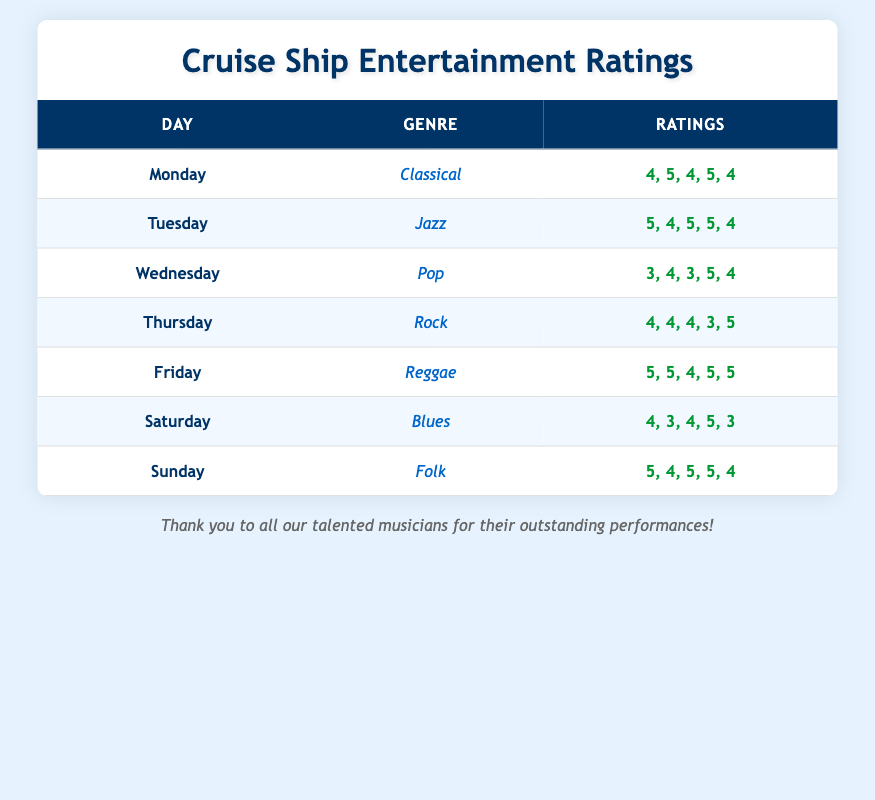What is the rating for Jazz performances on Tuesday? In the table, under the row for Tuesday, the genre is Jazz, and the ratings are listed as 5, 4, 5, 5, 4.
Answer: 5, 4, 5, 5, 4 Which genre received the highest average rating? To find the highest average, we calculate the average rating for each genre. Classical: (4+5+4+5+4)/5 = 4.4, Jazz: (5+4+5+5+4)/5 = 4.6, Pop: (3+4+3+5+4)/5 = 3.8, Rock: (4+4+4+3+5)/5 = 4.0, Reggae: (5+5+4+5+5)/5 = 4.8, Blues: (4+3+4+5+3)/5 = 3.8, Folk: (5+4+5+5+4)/5 = 4.6. The highest average is 4.8 for Reggae.
Answer: Reggae What was the lowest rating for Pop performances? Under the Pop performances on Wednesday, the ratings are 3, 4, 3, 5, 4. The lowest rating visible is 3.
Answer: 3 Did Folk performances receive an average rating above 4? To check this, we calculate the average for Folk: (5+4+5+5+4)/5 = 4.6. Since 4.6 is greater than 4, the average rating is above 4.
Answer: Yes What is the total number of performances rated on Saturday? On Saturday, the Blues performances have 5 ratings listed: 4, 3, 4, 5, 3. Therefore, the total number of performances rated is 5.
Answer: 5 Which day had a performance rating that was all above 4? By examining the table, we find that Tuesday (Jazz: 5, 4, 5, 5, 4) and Friday (Reggae: 5, 5, 4, 5, 5) both have ratings where all numbers are above 4.
Answer: Tuesday and Friday What was the average rating for Rock performances? For Rock on Thursday, the ratings are 4, 4, 4, 3, 5. The average is calculated as (4+4+4+3+5)/5 = 4. The average rating is 4.
Answer: 4 Did any genre receive a perfect rating of 5 on all days? By reviewing the table, no genre has all ratings as 5 across all days. The closest is Reggae with ratings of 5 but one is 4.
Answer: No 